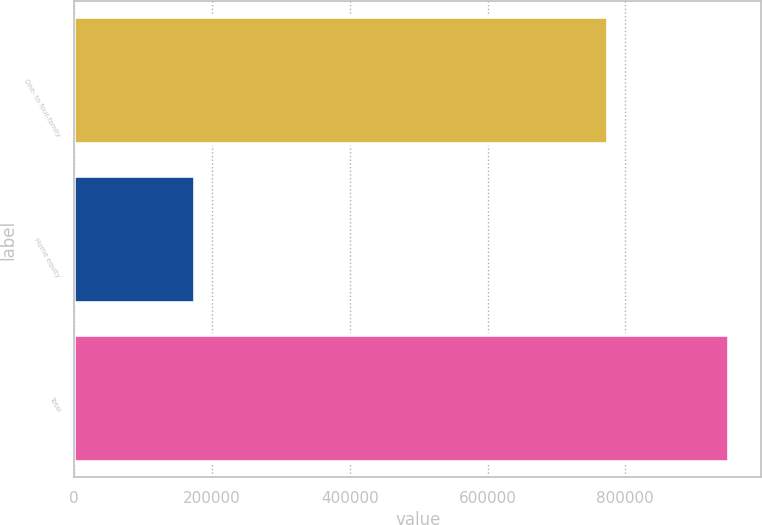<chart> <loc_0><loc_0><loc_500><loc_500><bar_chart><fcel>One- to four-family<fcel>Home equity<fcel>Total<nl><fcel>774328<fcel>175655<fcel>949983<nl></chart> 